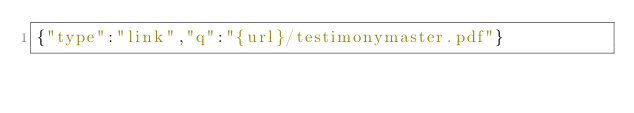Convert code to text. <code><loc_0><loc_0><loc_500><loc_500><_SML_>{"type":"link","q":"{url}/testimonymaster.pdf"}
</code> 